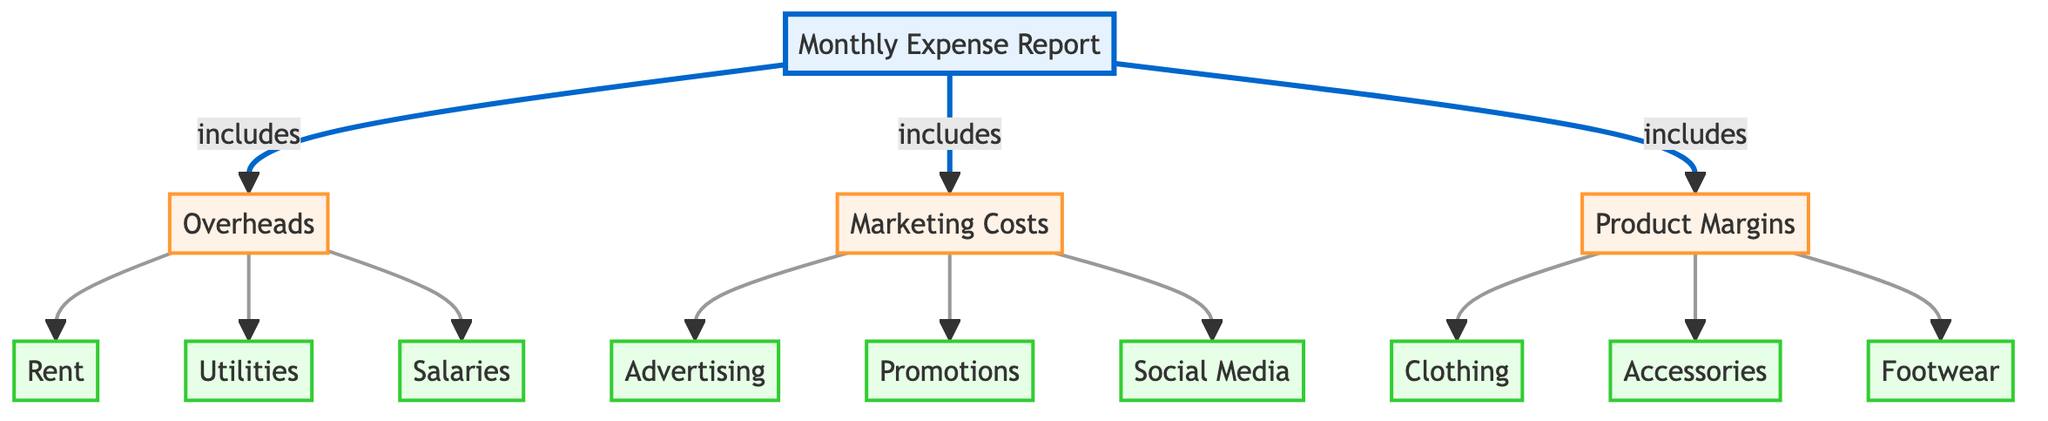What are the three main categories in the Monthly Expense Report? The diagram directly lists three categories under the Monthly Expense Report: Overheads, Marketing Costs, and Product Margins.
Answer: Overheads, Marketing Costs, Product Margins How many detailed items are listed under Overheads? In the diagram, there are three detailed items connected to the Overheads node: Rent, Utilities, and Salaries. Counting these items gives a total of three.
Answer: 3 What type of costs are included under Marketing Costs? The diagram specifies three items connected to the Marketing Costs node: Advertising, Promotions, and Social Media, indicating the types of costs involved.
Answer: Advertising, Promotions, Social Media How many product categories are identified under Product Margins? The diagram shows three product categories linked to the Product Margins node: Clothing, Accessories, and Footwear. Counting these reveals that there are three categories.
Answer: 3 Which category includes Rent? The diagram indicates that Rent is a detailed item under the Overheads category, as indicated by the arrow leading from Overheads to Rent.
Answer: Overheads What connects the Monthly Expense Report to Overheads, Marketing Costs, and Product Margins? The diagram shows that the Monthly Expense Report includes each of the three categories connected by arrows, indicating a direct relationship from the Monthly Expense Report to each category.
Answer: Includes Which marketing item appears last in the list? The items listed under Marketing Costs in the diagram are connected in the order of Advertising, Promotions, and Social Media. Thus, the last item in this sequence is Social Media.
Answer: Social Media How are the marketing costs organized in the diagram? The diagram organizes marketing costs as a single node (Marketing Costs) with three detailed sub-items (Advertising, Promotions, Social Media) branching out from it, showing a hierarchy.
Answer: Hierarchy What differentiates Product Margins from Overheads in the diagram? In the diagram, Product Margins and Overheads are two distinct categories under the Monthly Expense Report, with Product Margins relating to products sold and Overheads relating to general business costs.
Answer: Distinct categories 